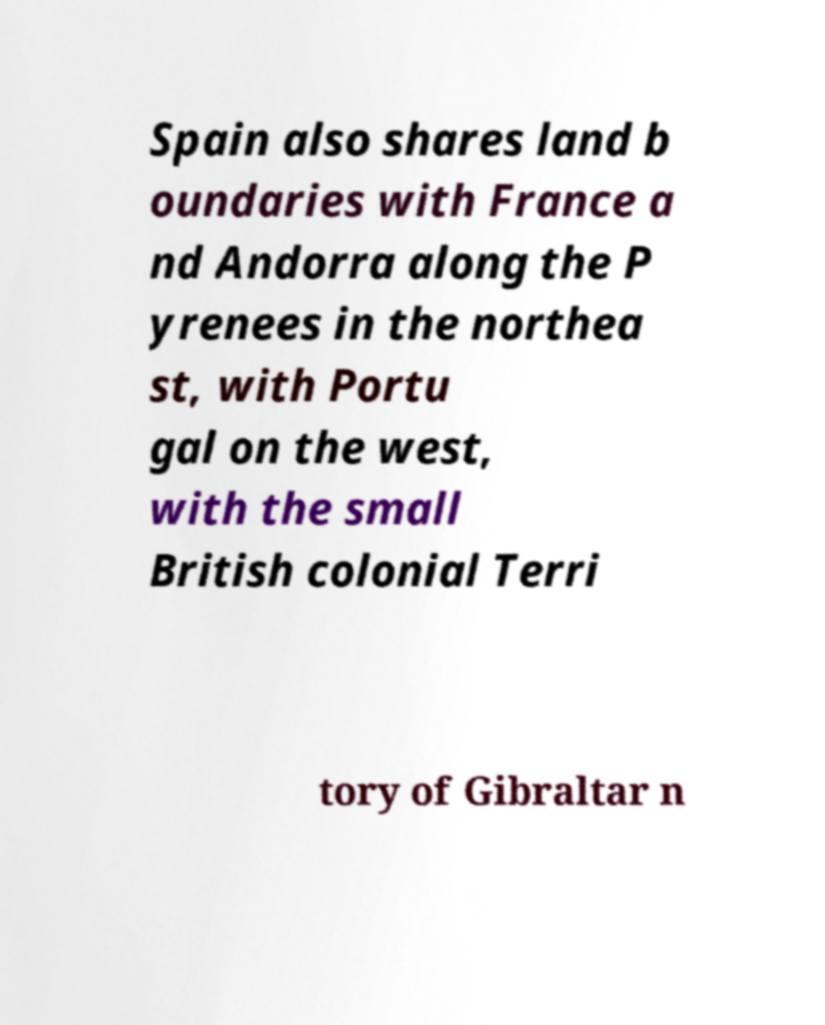What messages or text are displayed in this image? I need them in a readable, typed format. Spain also shares land b oundaries with France a nd Andorra along the P yrenees in the northea st, with Portu gal on the west, with the small British colonial Terri tory of Gibraltar n 